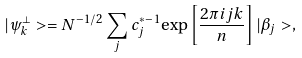Convert formula to latex. <formula><loc_0><loc_0><loc_500><loc_500>| { \psi } ^ { \perp } _ { k } > = N ^ { - 1 / 2 } \sum _ { j } c ^ { * - 1 } _ { j } { \exp } \left [ { \frac { 2 { \pi } i j k } { n } } \right ] | { \beta } _ { j } > ,</formula> 